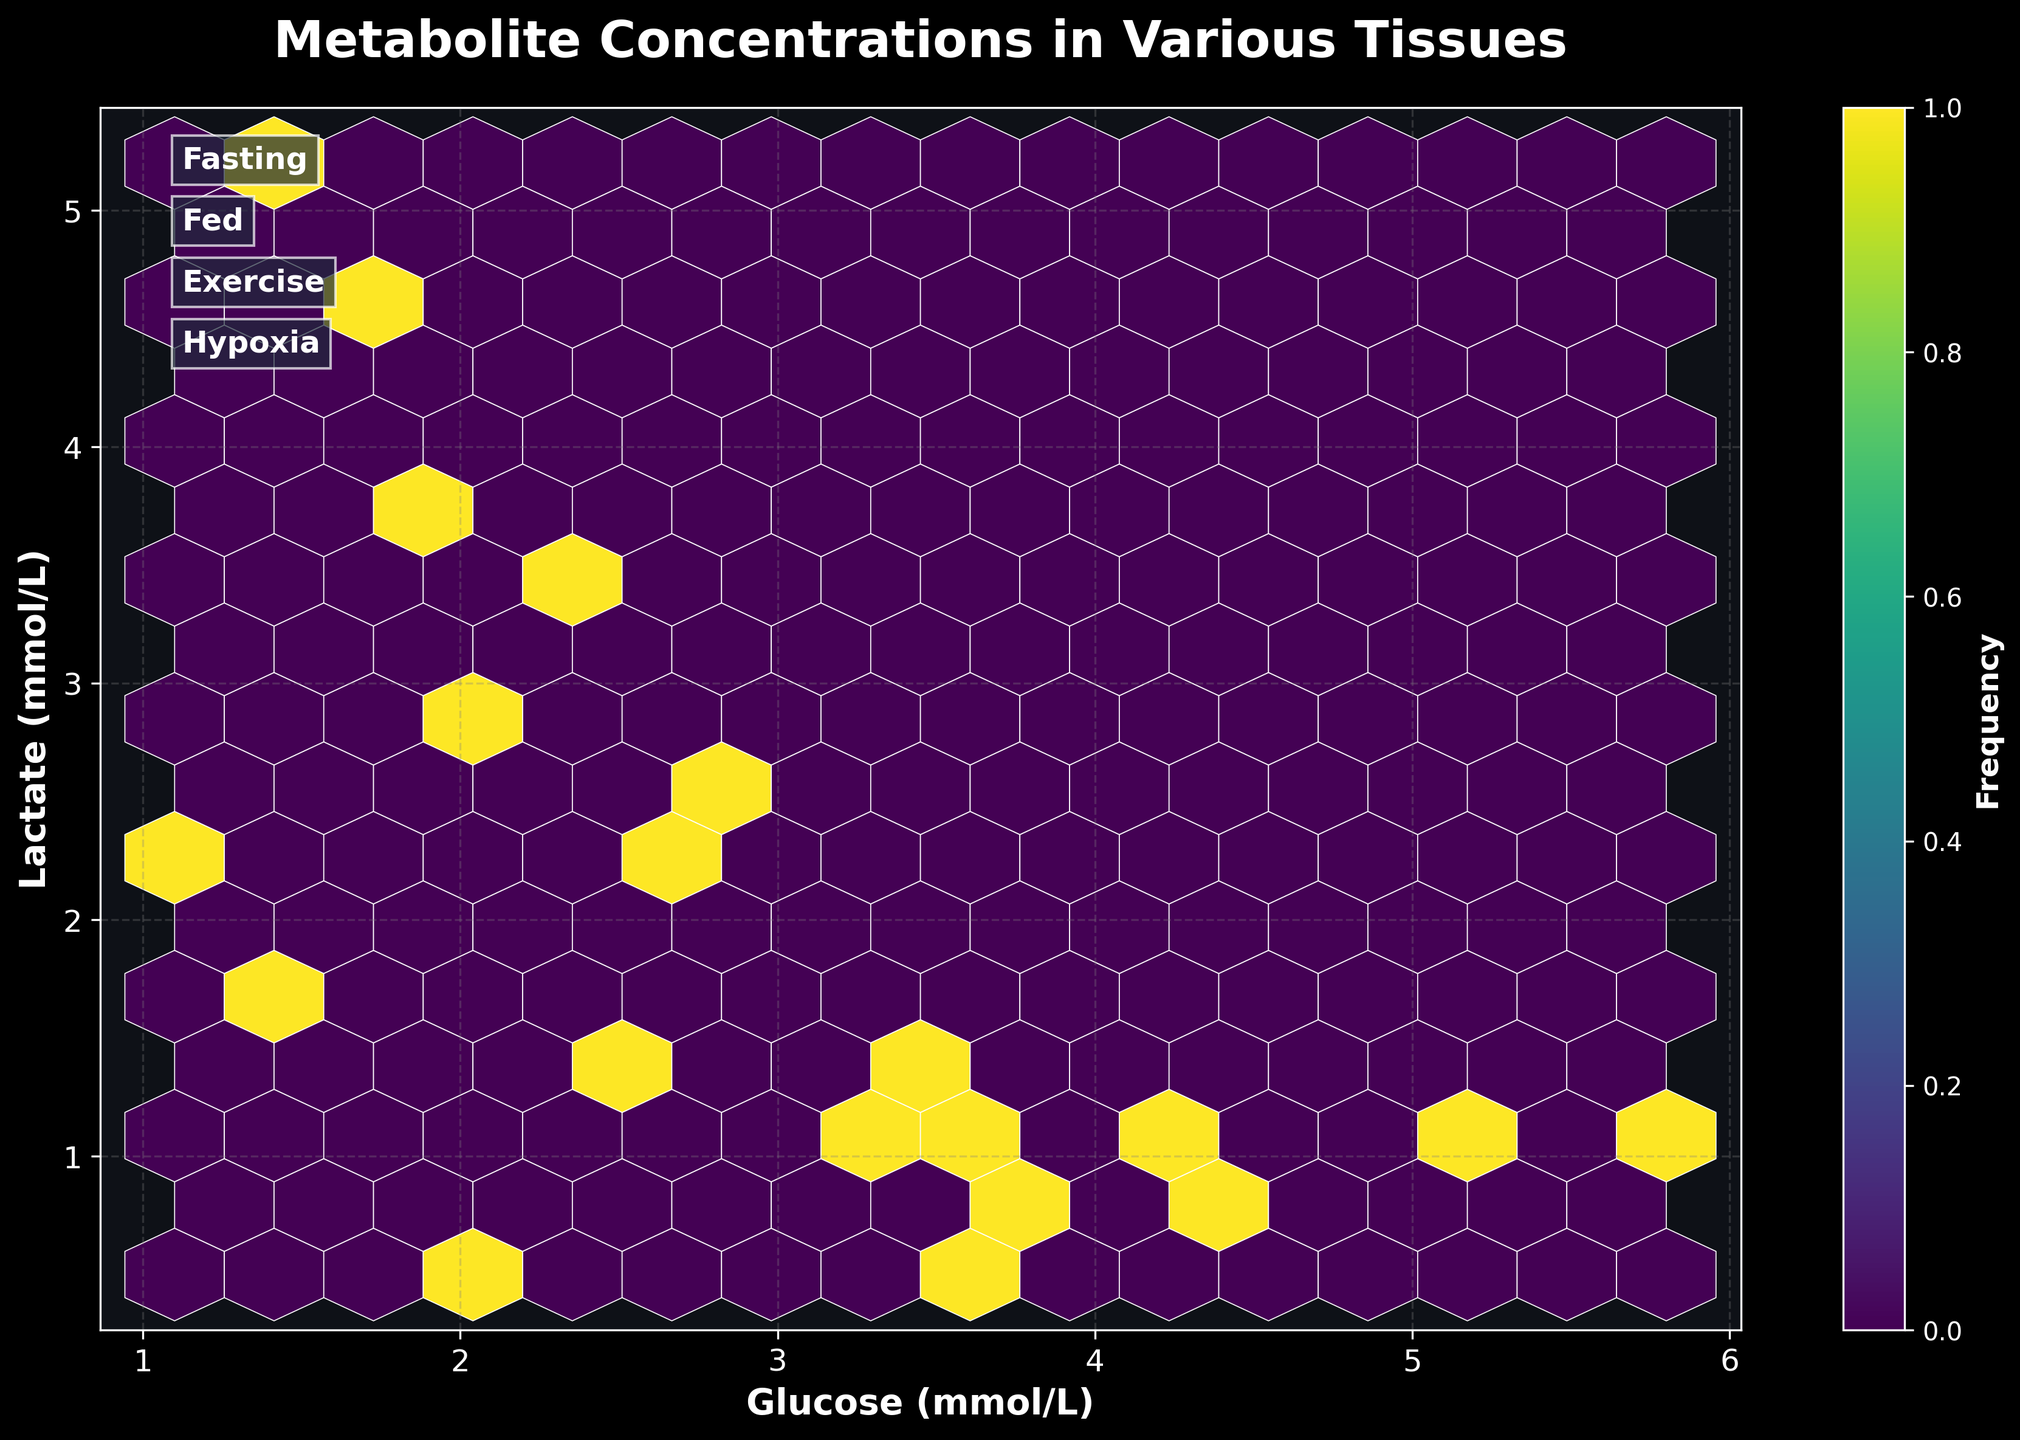What is the title of the hexbin plot? The title of the plot is visible at the top and reads: "Metabolite Concentrations in Various Tissues".
Answer: Metabolite Concentrations in Various Tissues How many hexagons are used to represent the data in the plot? The gridsize parameter in the code is set to 15, meaning the plot will be divided into hexagons forming a grid where each hexagon is part of a 15x15 grid.
Answer: 15 What do the colors in the hexbin plot represent? The colors in the plot correspond to the frequency of data points within each hexagon, indicated by the colorbar labeled "Frequency" on the right side of the plot.
Answer: Frequency What are the x-axis and y-axis labels? The x-axis is labeled "Glucose (mmol/L)" and the y-axis is labeled "Lactate (mmol/L)", indicating the metabolite concentrations being plotted.
Answer: Glucose (mmol/L) and Lactate (mmol/L) Which condition annotations are displayed on the plot and where are they located? The condition annotations are "Fasting", "Fed", "Exercise", and "Hypoxia". They are positioned at different points on the plot using `ax.annotate` and are displayed on the right side of the plot.
Answer: Fasting, Fed, Exercise, and Hypoxia Which condition seems to have the highest lactate concentration across different tissues? By looking at the distribution of points, the condition with higher lactate concentrations tends to be "Hypoxia", as indicated by noticeable hexagon clusters in the upper right portion of the plot.
Answer: Hypoxia What is the approximate range of glucose concentrations observed in the dataset? Observing the spread of the hexagons along the x-axis, glucose concentrations range approximately from 1.1 mmol/L to 5.8 mmol/L.
Answer: 1.1 to 5.8 mmol/L Which tissue has the lowest observed glucose concentration under any condition? Adipose tissue under the "Hypoxia" condition has the lowest glucose concentration observed, approximately 1.1 mmol/L.
Answer: Adipose under Hypoxia How would you describe the correlation between glucose and lactate concentrations based on the hexbin plot? The plot shows a tendency where lower glucose concentrations are associated with higher lactate concentrations, particularly under "Exercise" and "Hypoxia" conditions, suggesting a negative correlation.
Answer: Negative correlation Can you identify any outliers in the plot, particularly with high glucose but low lactate or vice versa? There are a few isolated hexagons where glucose levels are high (around 5.8 mmol/L) but lactate levels are low (less than 1 mmol/L), likely indicating an outlier for the "Fed" condition in the Liver tissue.
Answer: High glucose and low lactate in Liver (Fed) 